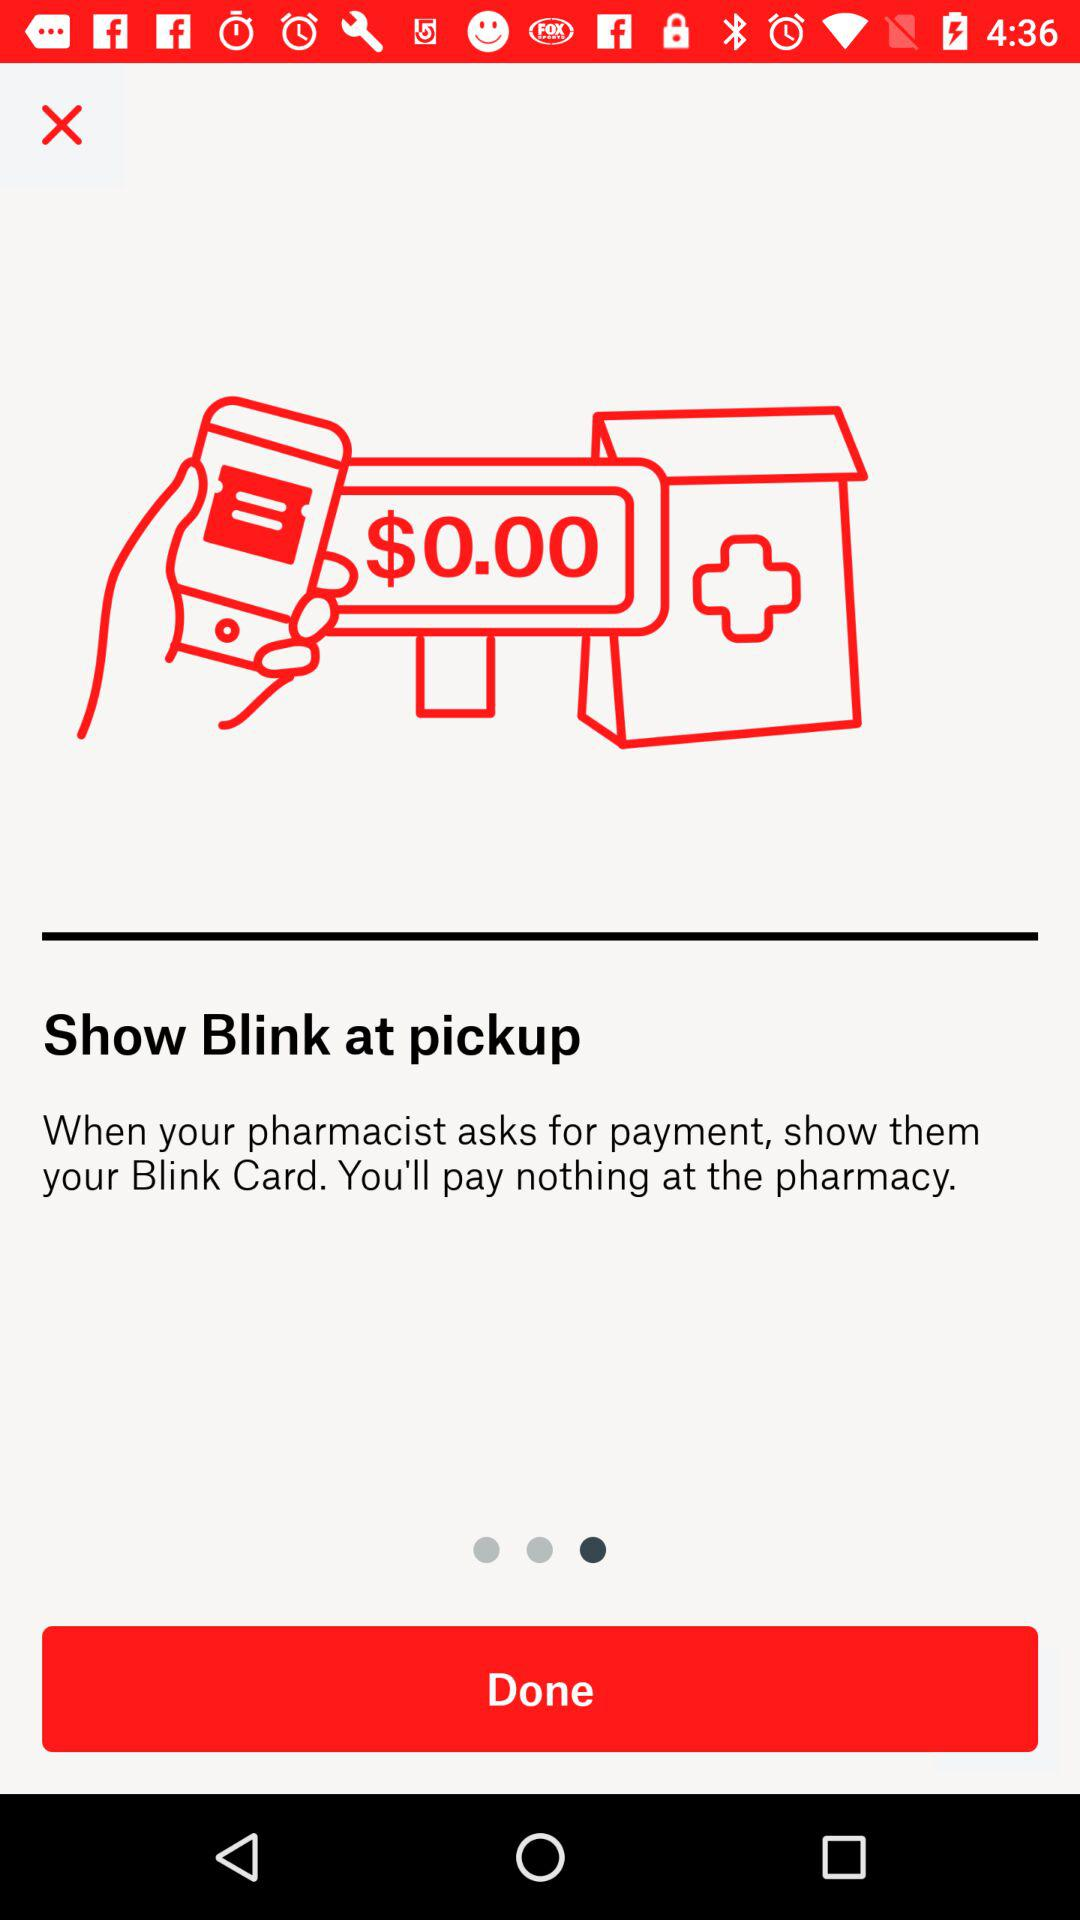How much did I pay for my prescription?
Answer the question using a single word or phrase. $0.00 